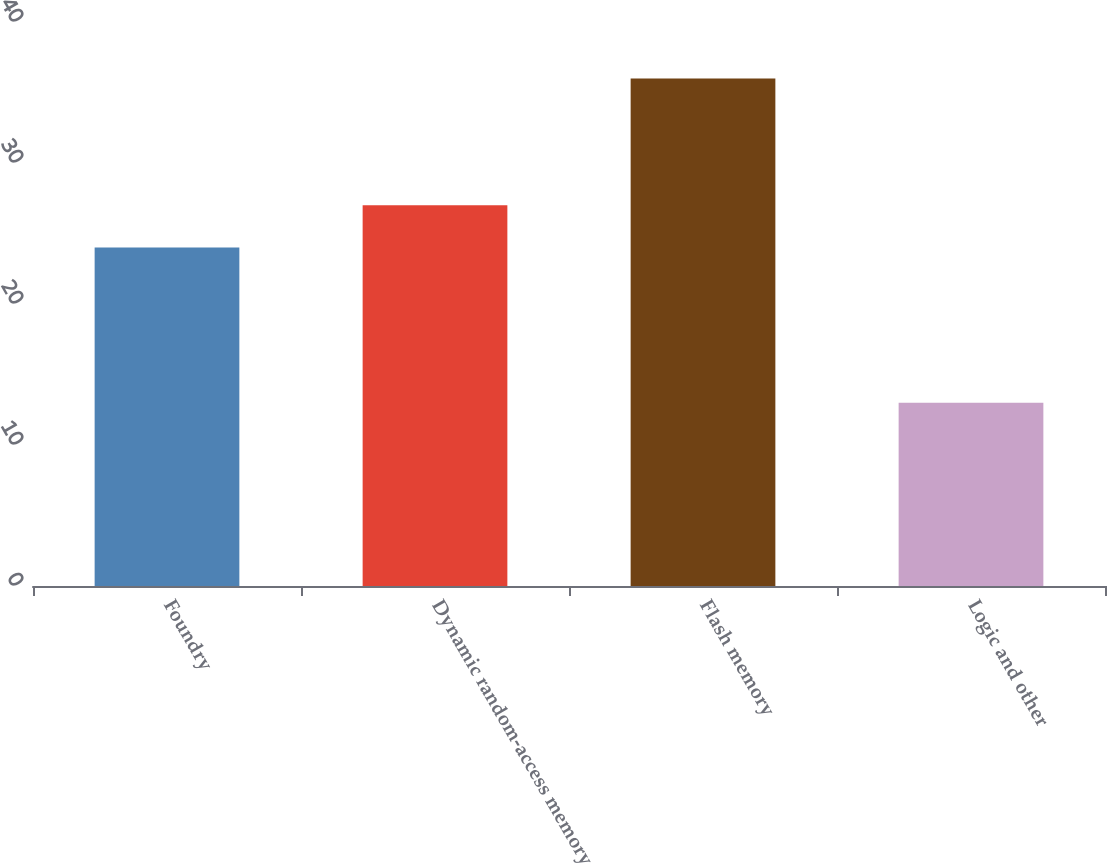Convert chart. <chart><loc_0><loc_0><loc_500><loc_500><bar_chart><fcel>Foundry<fcel>Dynamic random-access memory<fcel>Flash memory<fcel>Logic and other<nl><fcel>24<fcel>27<fcel>36<fcel>13<nl></chart> 